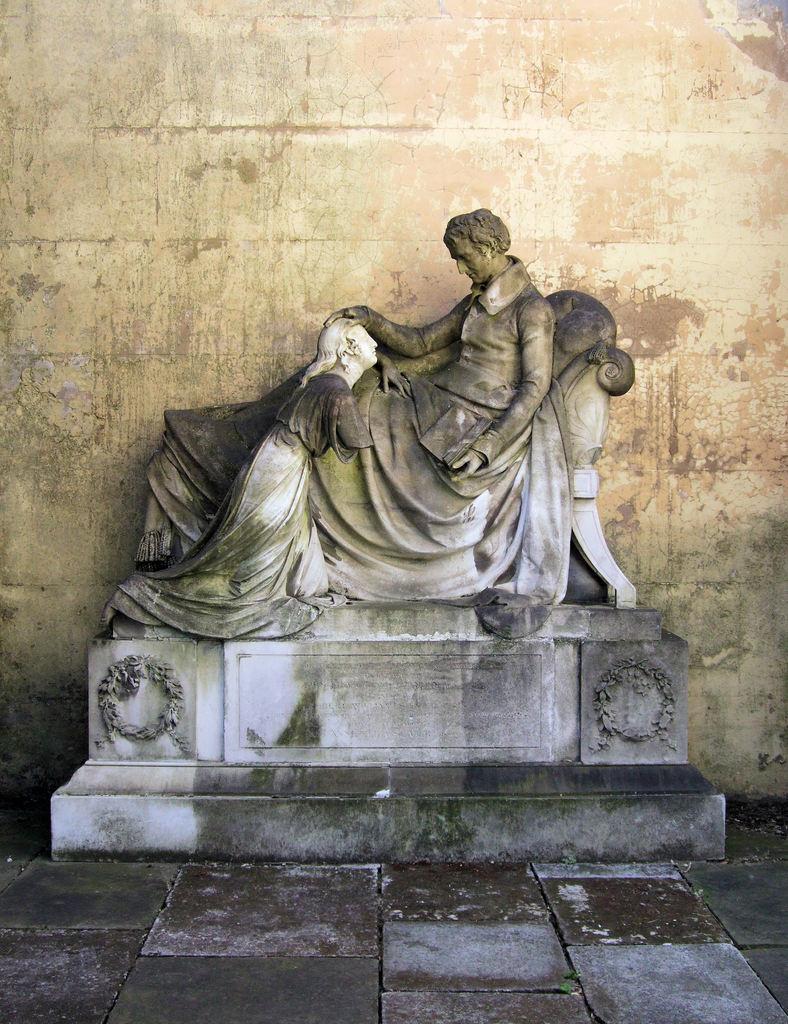Describe this image in one or two sentences. In this image we can see a statue. On the backside we can see a wall. 